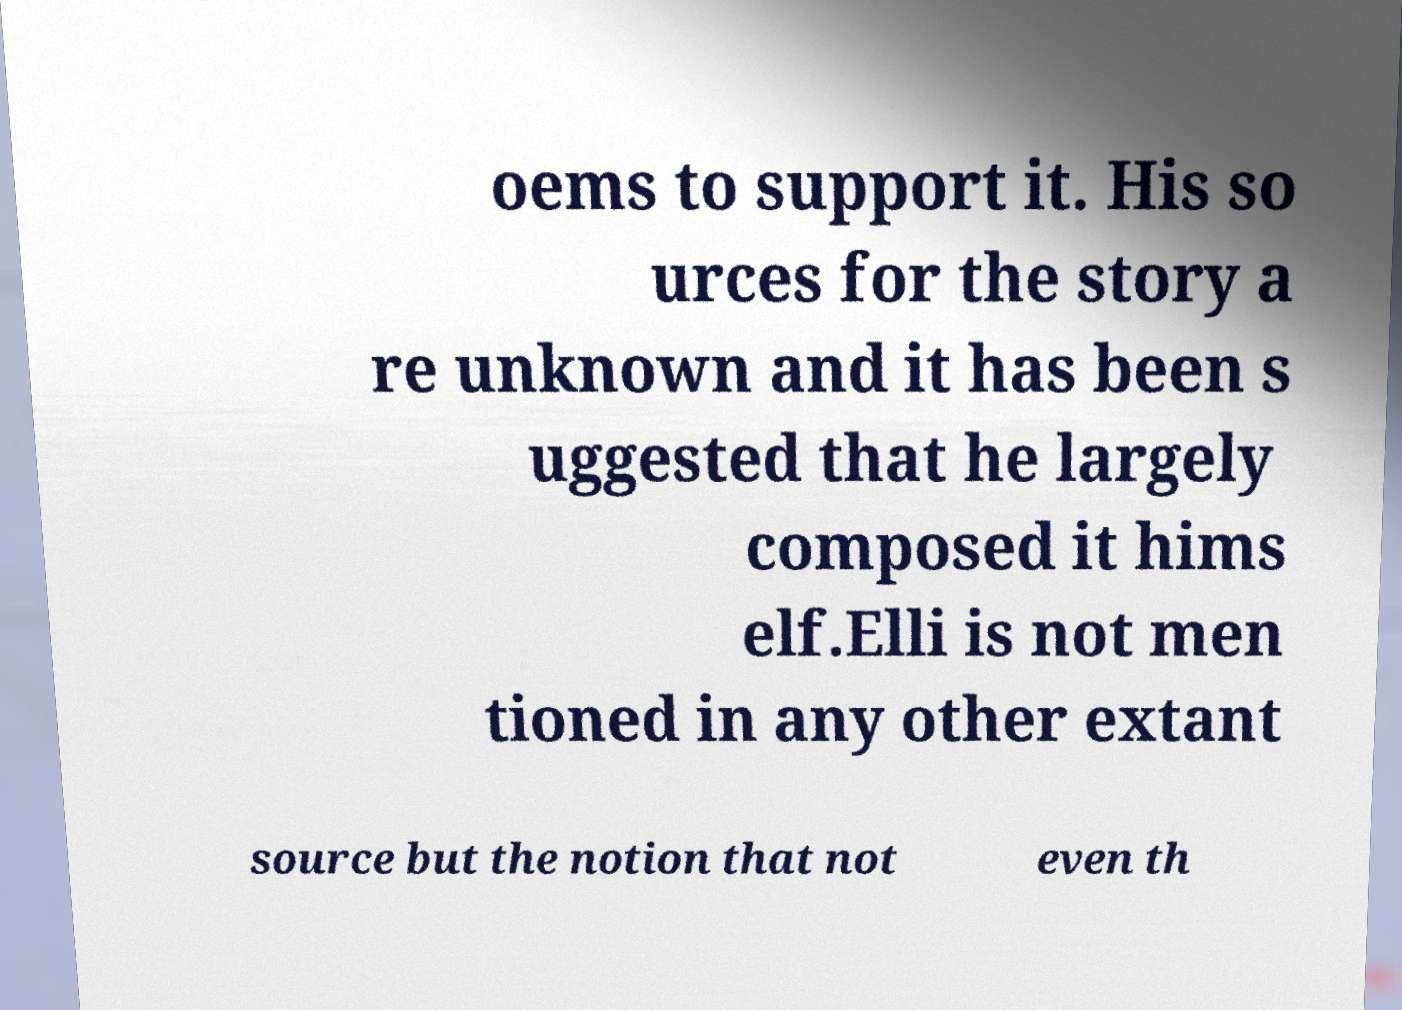There's text embedded in this image that I need extracted. Can you transcribe it verbatim? oems to support it. His so urces for the story a re unknown and it has been s uggested that he largely composed it hims elf.Elli is not men tioned in any other extant source but the notion that not even th 